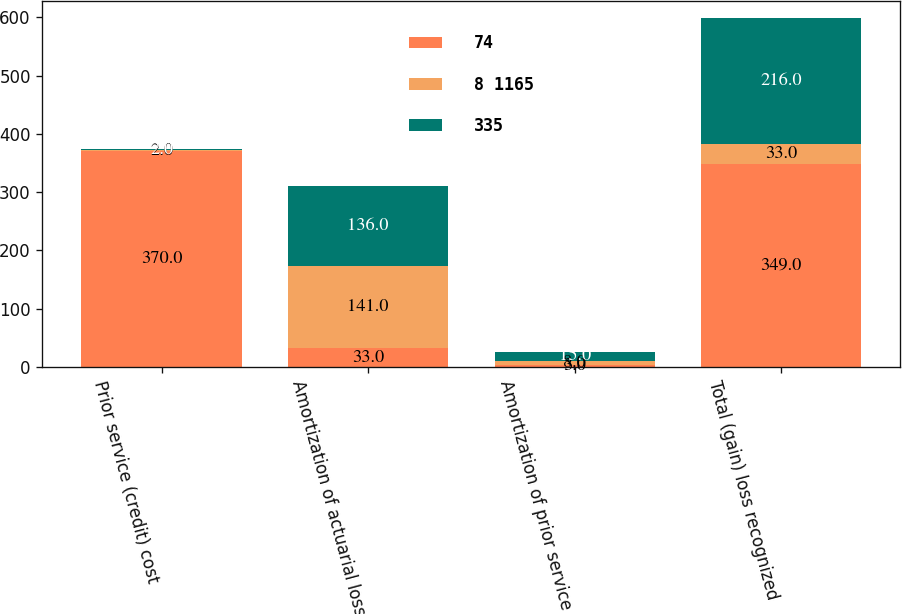<chart> <loc_0><loc_0><loc_500><loc_500><stacked_bar_chart><ecel><fcel>Prior service (credit) cost<fcel>Amortization of actuarial loss<fcel>Amortization of prior service<fcel>Total (gain) loss recognized<nl><fcel>74<fcel>370<fcel>33<fcel>3<fcel>349<nl><fcel>8 1165<fcel>2<fcel>141<fcel>8<fcel>33<nl><fcel>335<fcel>2<fcel>136<fcel>15<fcel>216<nl></chart> 